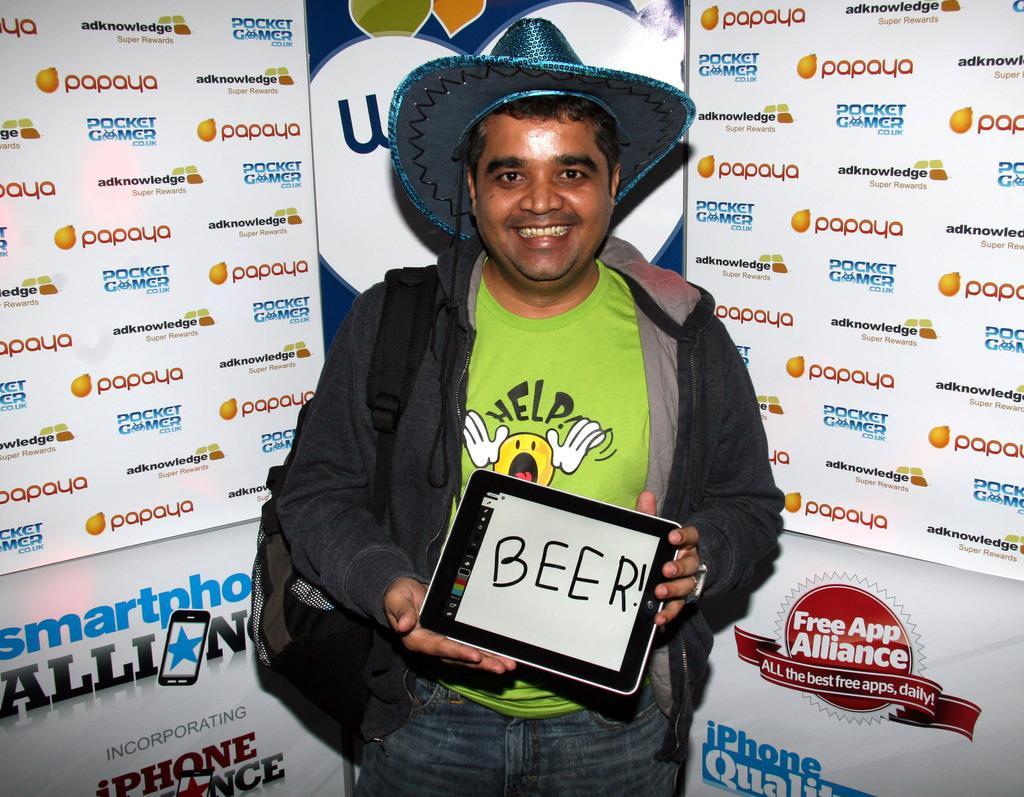How would you summarize this image in a sentence or two? In this picture I can see a man wearing a hat and holding a tab. And i can see hoarding in the background 